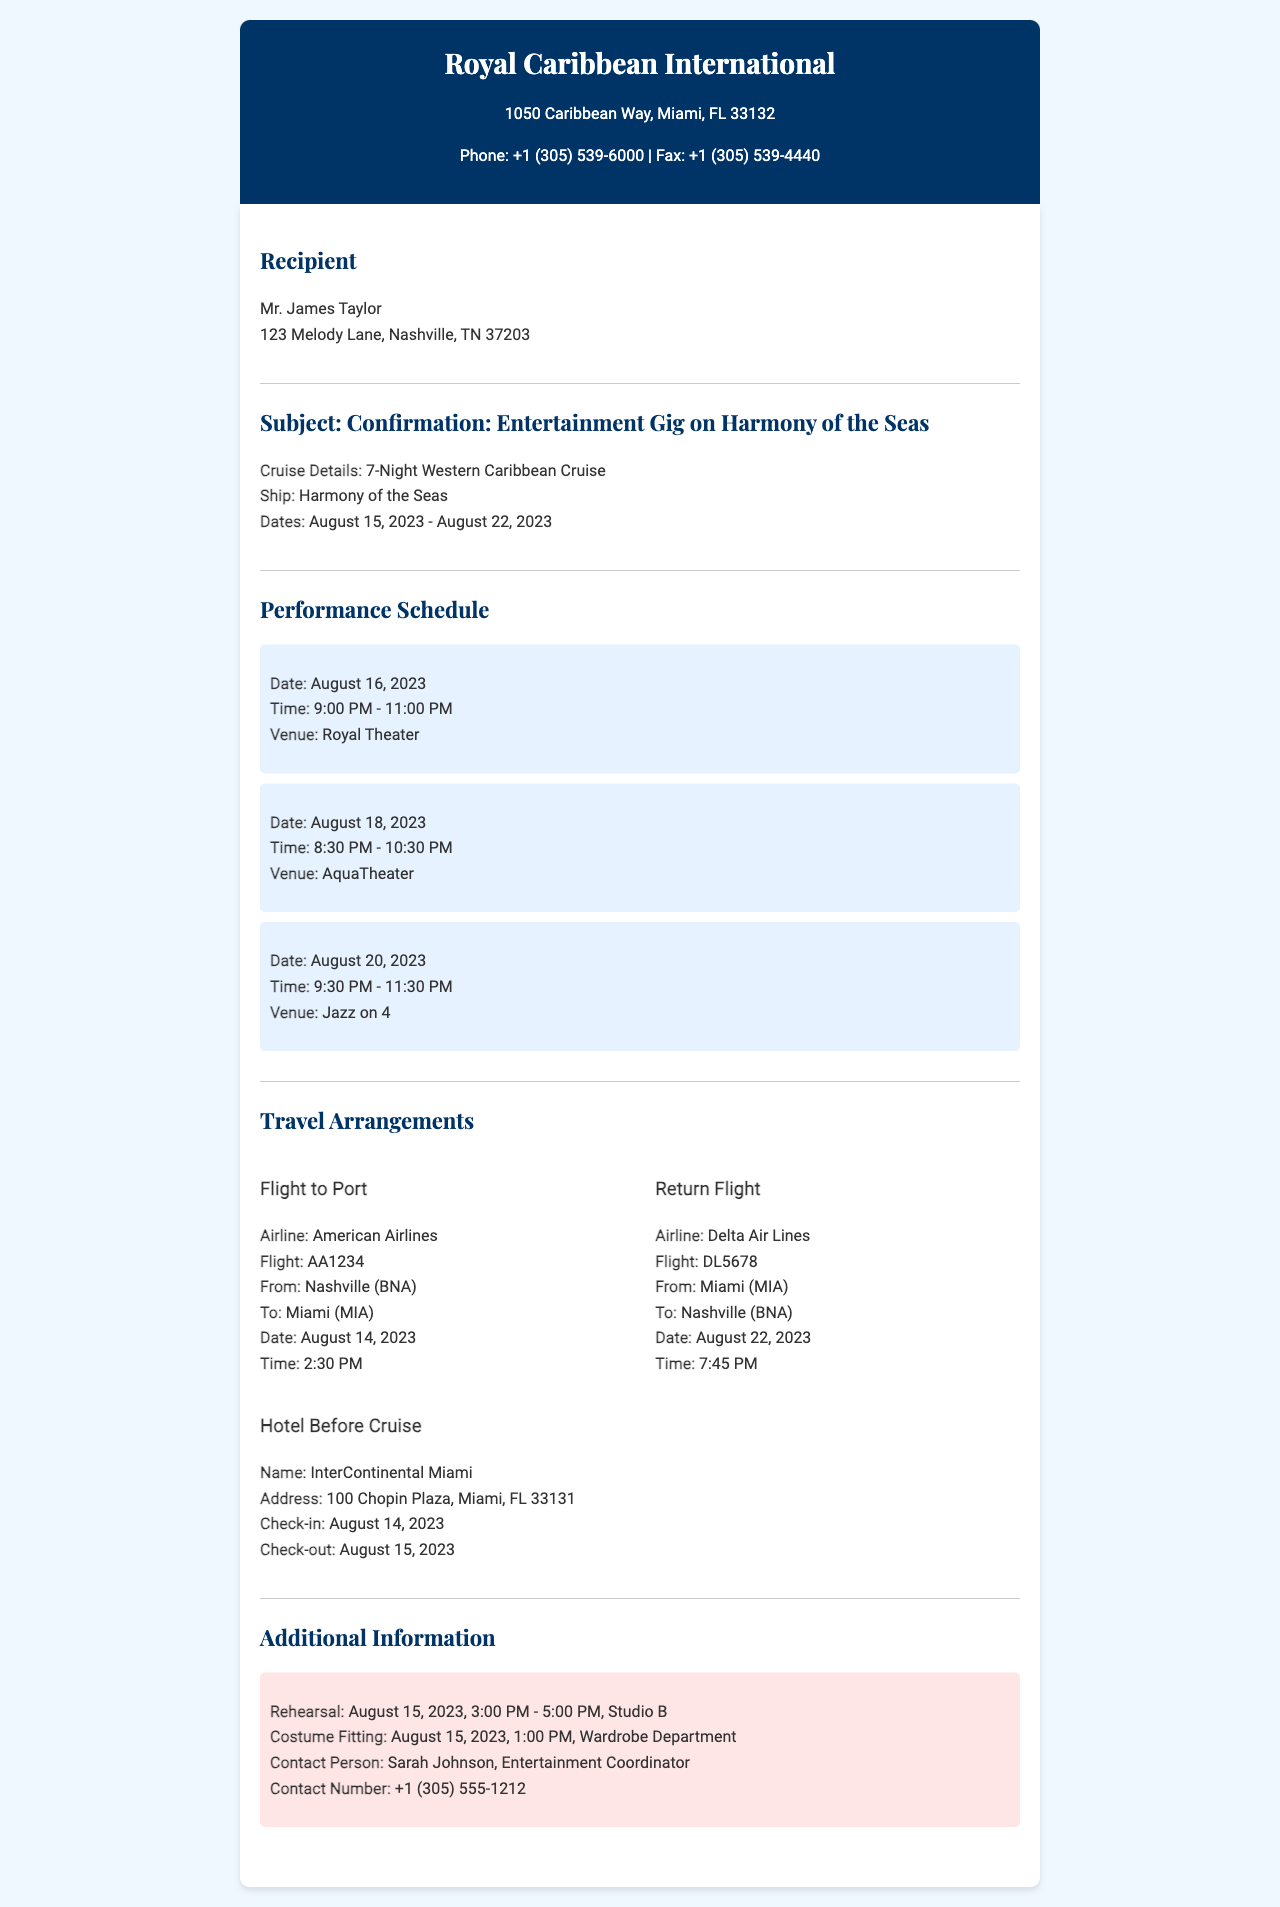What are the performance dates? The performance dates are mentioned in the "Cruise Details" section as August 15, 2023 to August 22, 2023.
Answer: August 15, 2023 - August 22, 2023 What is the return flight time? The return flight time is listed in the "Return Flight" section of the travel arrangements, which states it departs at 7:45 PM.
Answer: 7:45 PM What is the venue for the performance on August 18, 2023? The venue for the performance on this date is provided in the "Performance Schedule" section, specifically for that date.
Answer: AquaTheater Who is the contact person for the event? The contact person is found in the "Additional Information" section, where it mentions Sarah Johnson as the coordinator.
Answer: Sarah Johnson What airline is used for the flight to Miami? The airline is specified in the "Flight to Port" section, which states American Airlines.
Answer: American Airlines How many nights is the cruise? The document states in the "Cruise Details" section that it is a 7-Night Western Caribbean Cruise.
Answer: 7-Night What is the hotel name before the cruise? The hotel name is mentioned under "Hotel Before Cruise" section which states the hotel name explicitly.
Answer: InterContinental Miami 